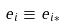Convert formula to latex. <formula><loc_0><loc_0><loc_500><loc_500>e _ { i } \equiv e _ { i * }</formula> 